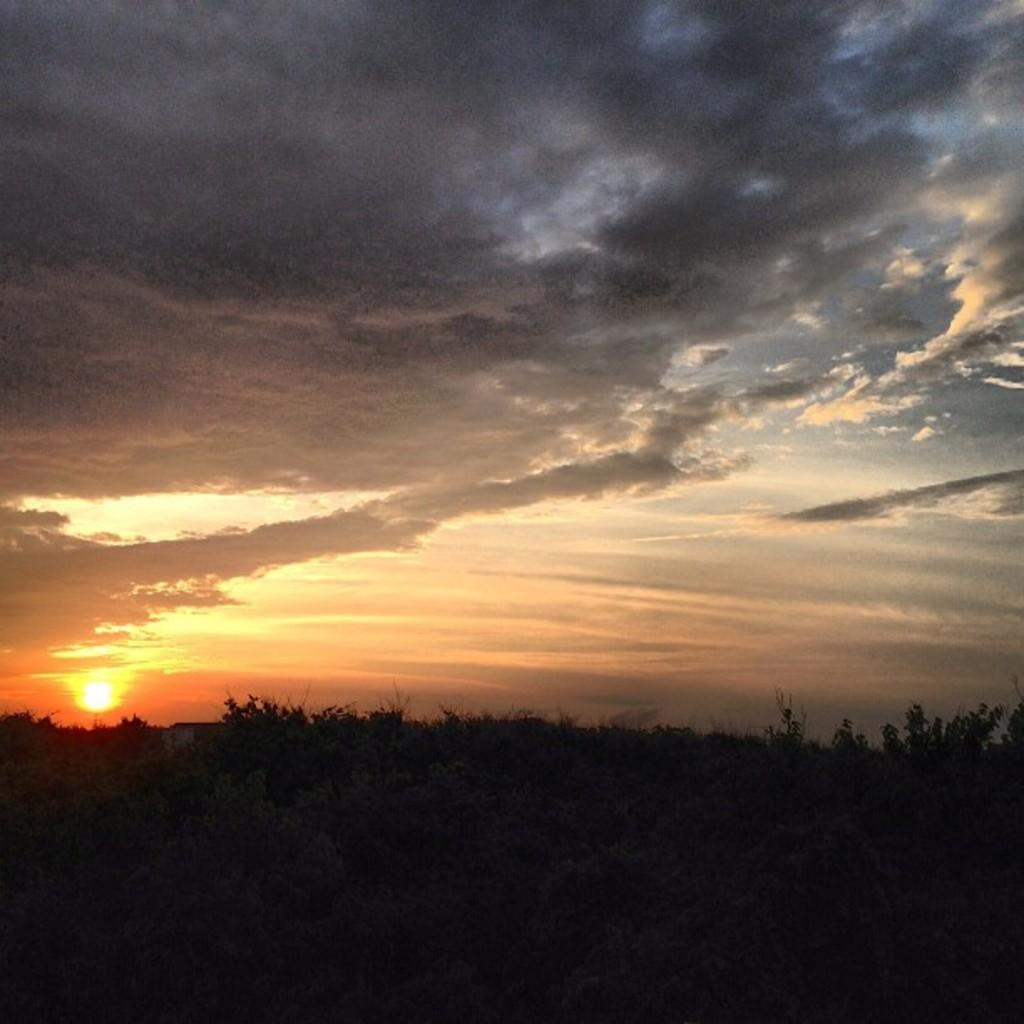What celestial body is present in the image? There is a sun in the image. What else can be seen in the sky in the image? The sky is visible in the image. What type of vegetation is present in the image? There are trees in the image. How would you describe the overall lighting in the image? The image appears to be dark. Can you see a book in the image? There is no book present in the image. 